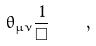<formula> <loc_0><loc_0><loc_500><loc_500>\theta _ { \mu \nu } \frac { 1 } { \Box } \quad ,</formula> 